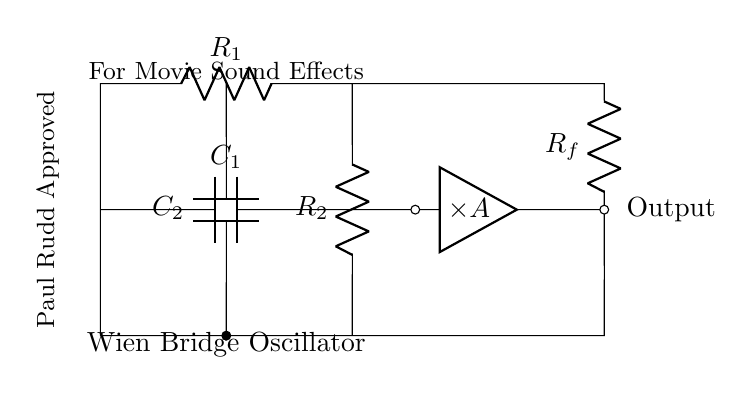What type of oscillator is depicted in this circuit? The circuit is labeled as a "Wien Bridge Oscillator," which is designed to produce audio tones. The label directly provides the type of oscillator being represented.
Answer: Wien Bridge Oscillator Which components are connected in series on the top branch? The top branch connects the resistor R1 and then leads directly to the output node; hence, R1 is the only component in series at that position in the circuit.
Answer: R1 How many capacitors are in the circuit? There are two capacitors shown in the circuit diagram, C1 and C2, which are clearly labeled and visible.
Answer: 2 What is the purpose of the amplifier in this circuit? The amplifier labeled "A" enhances the signal generated by the oscillator circuit, which is essential for boosting the audio tone output to a usable level, facilitating the application in sound effects.
Answer: Amplification What role does the feedback resistor Rf play in this oscillator? The feedback resistor Rf is crucial for determining the oscillator's gain and stability, ensuring that the circuit can maintain oscillations by providing the necessary feedback. Rf is connected to the input of the amplifier, fulfilling this role.
Answer: Gain control What is the function of capacitors C1 and C2 in the Wien Bridge Oscillator? C1 and C2 are part of the frequency-determining network of the oscillator. Their values affect the frequency of the audio tones generated. The circuit relies on these capacitors to set the oscillation frequency.
Answer: Frequency-determining 